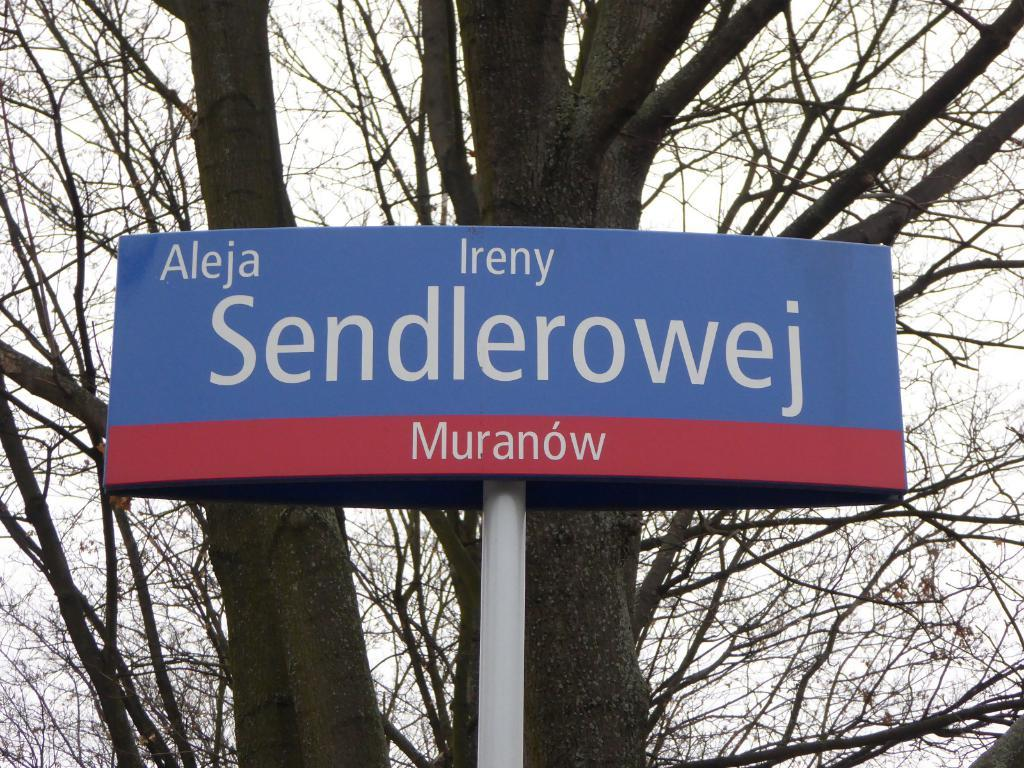What is the main object in the image? There is a blue color board in the image. How is the board attached to the pole? The board is fixed to a white color pole. What can be found on the board? There is text on the board. What can be seen in the background of the image? There are trees and the sky visible in the background of the image. What type of reaction does the steel have to the operation in the image? There is no steel or operation present in the image; it features a blue color board fixed to a white color pole with text on it, and a background with trees and the sky. 